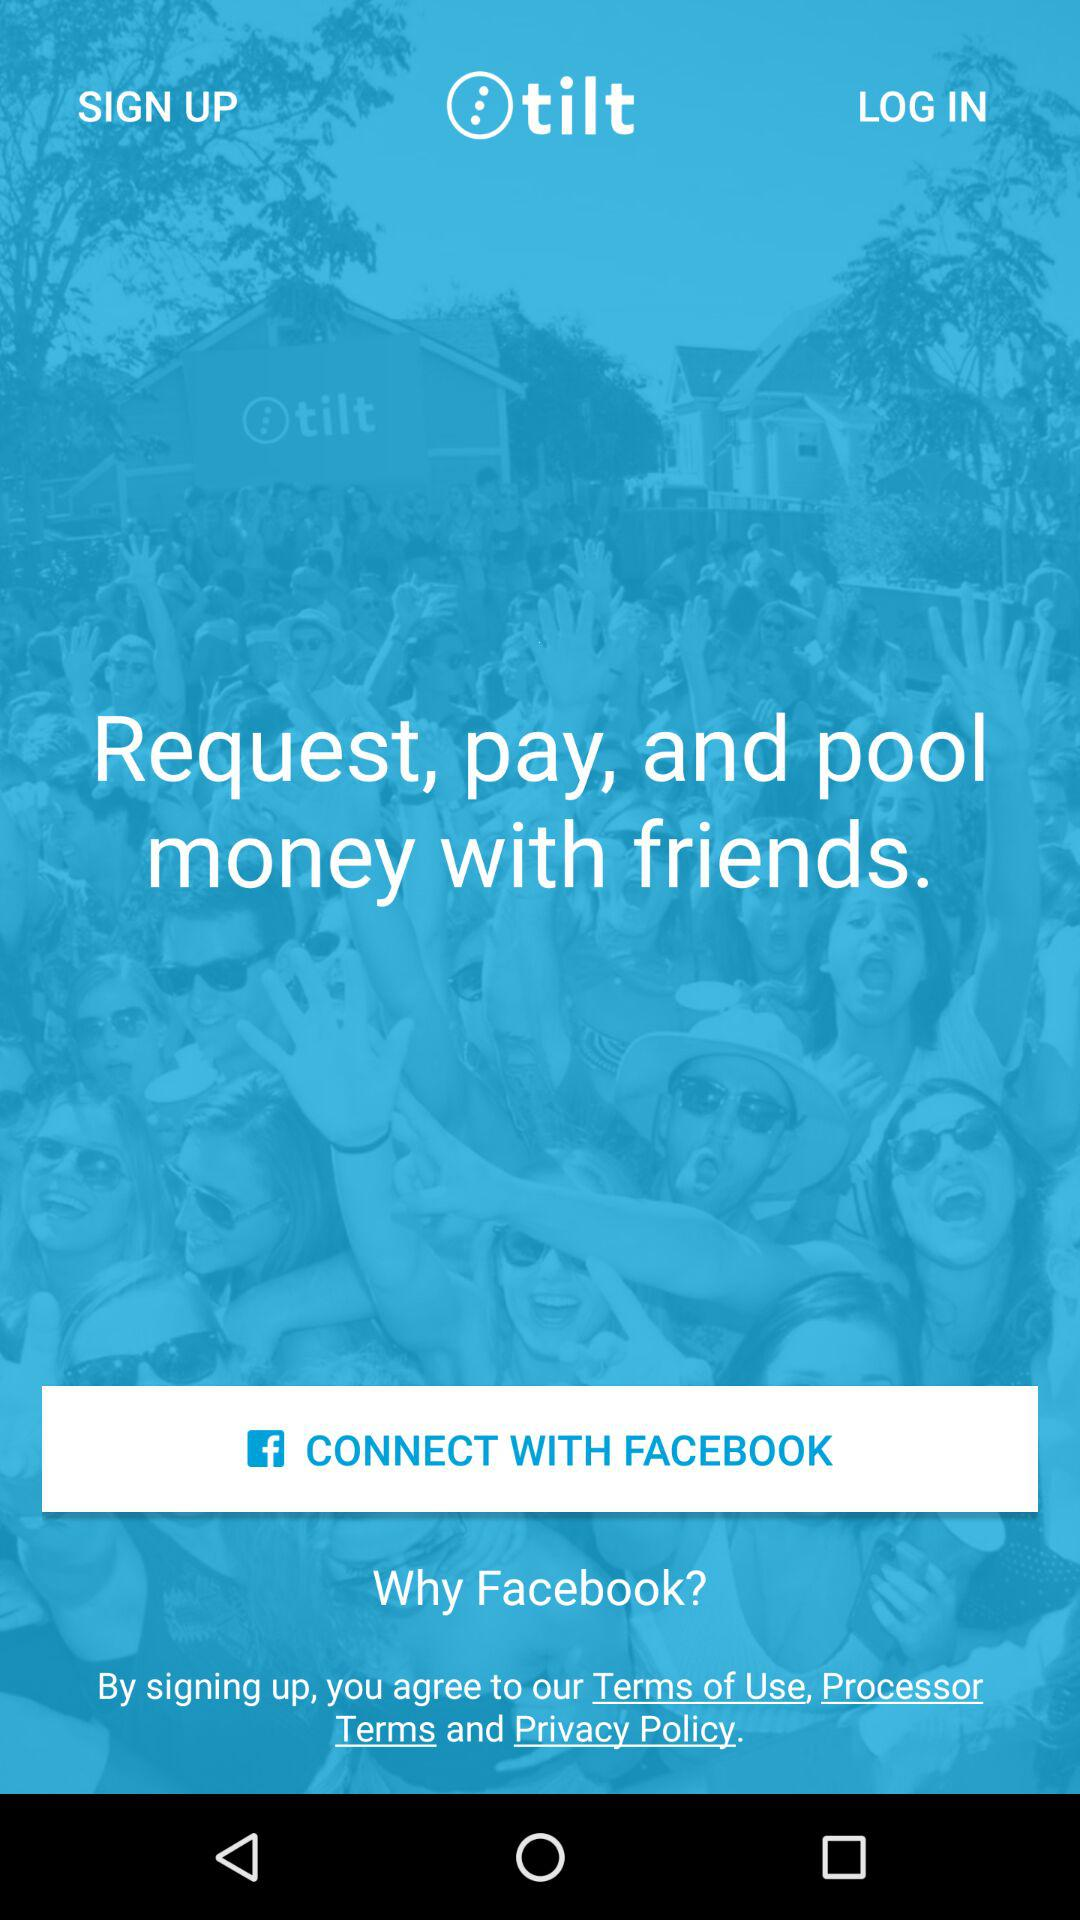What's the application name? The application name is "tilt". 